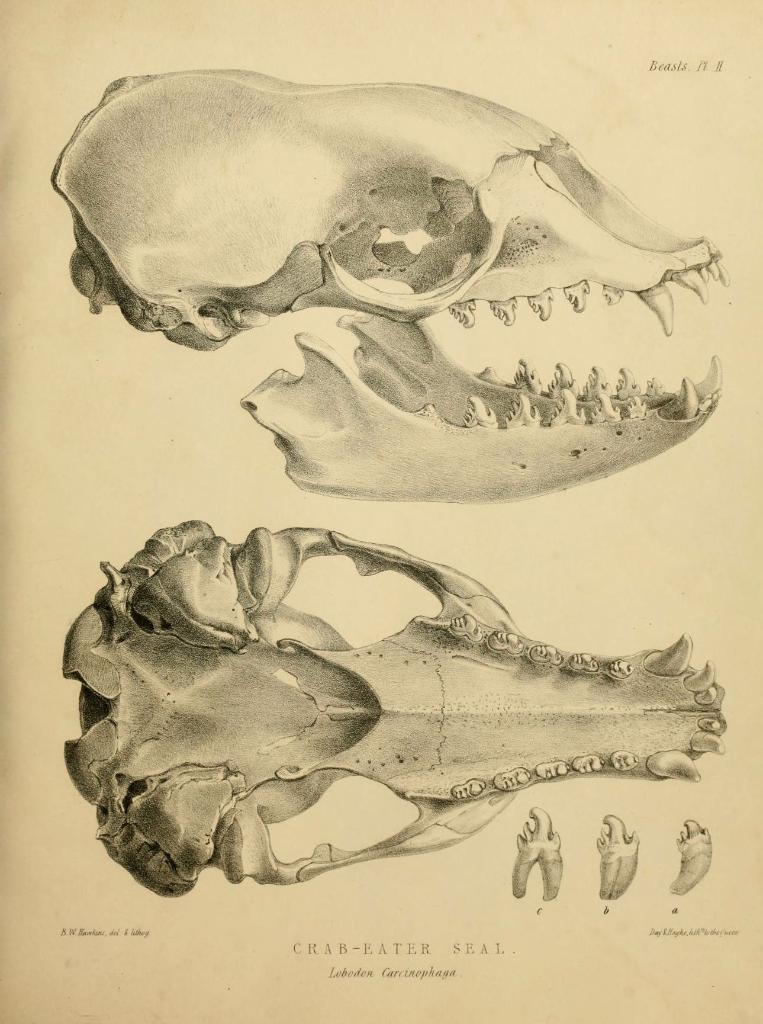Describe this image in one or two sentences. This is the drawing image and there is some text written on it. 